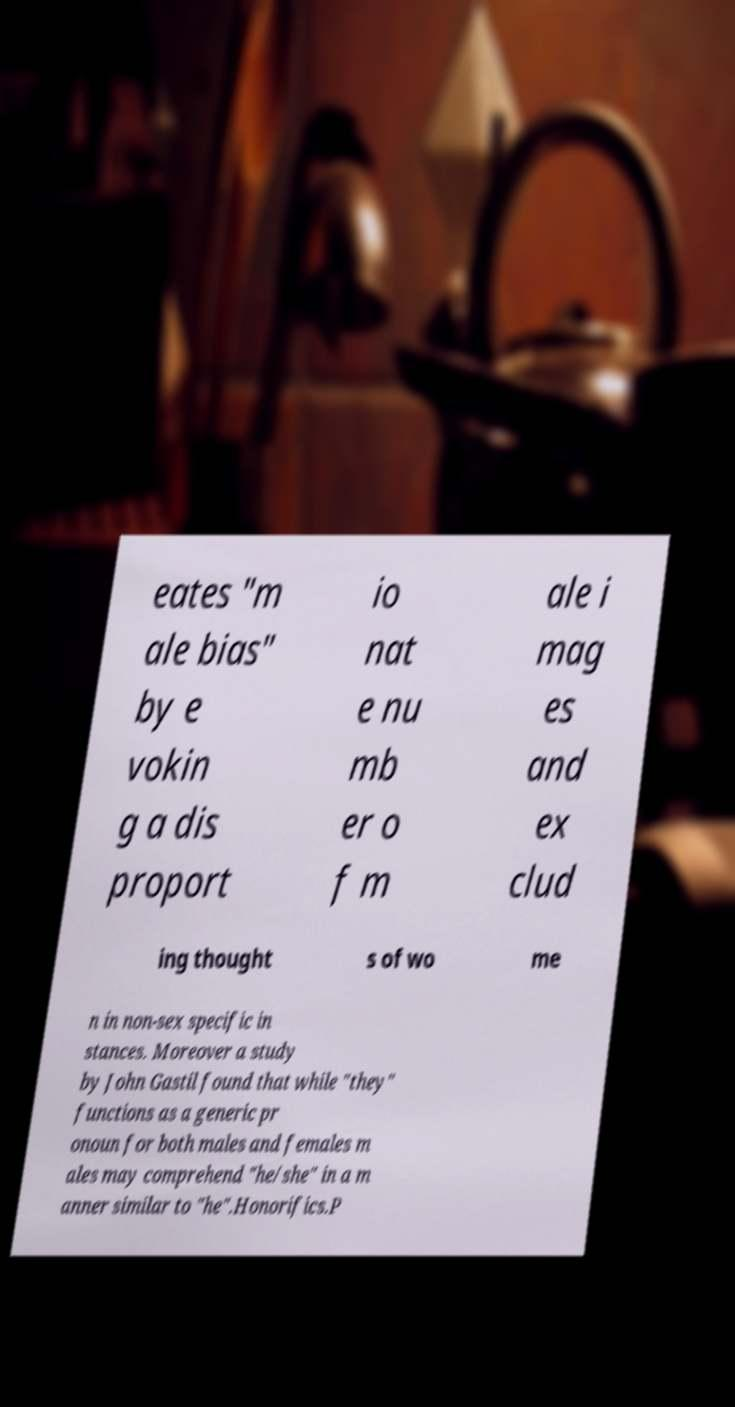For documentation purposes, I need the text within this image transcribed. Could you provide that? eates "m ale bias" by e vokin g a dis proport io nat e nu mb er o f m ale i mag es and ex clud ing thought s of wo me n in non-sex specific in stances. Moreover a study by John Gastil found that while "they" functions as a generic pr onoun for both males and females m ales may comprehend "he/she" in a m anner similar to "he".Honorifics.P 